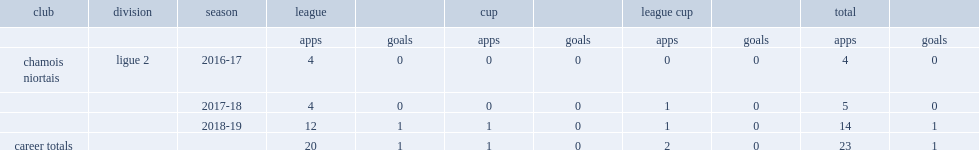Which season did quentin bena join ligue 2 club chamois niortais? 2017-18. 